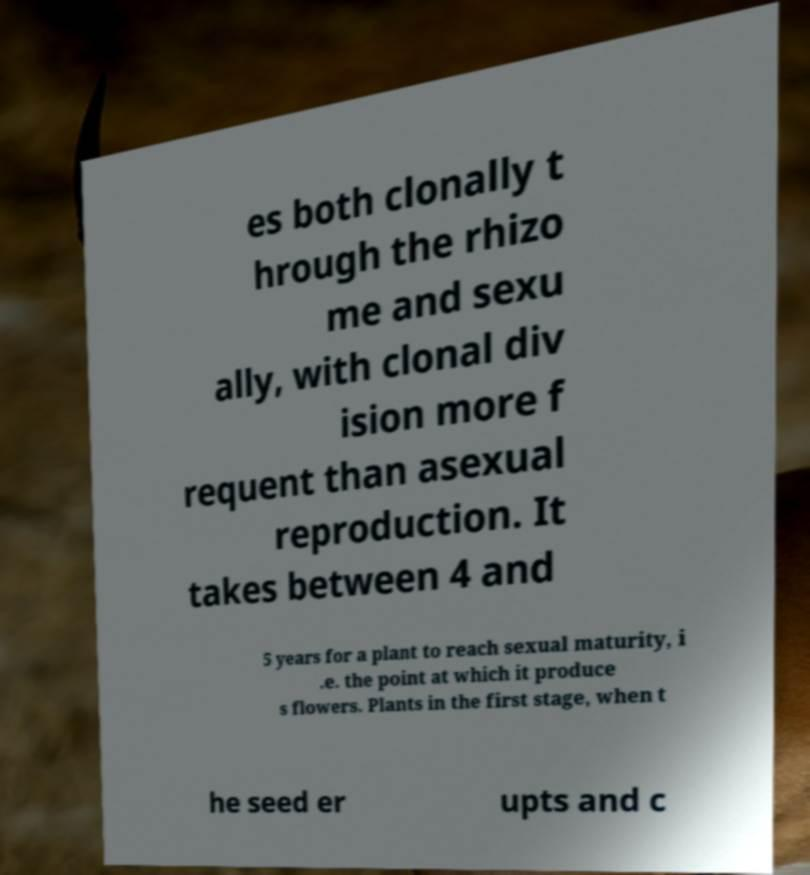Can you accurately transcribe the text from the provided image for me? es both clonally t hrough the rhizo me and sexu ally, with clonal div ision more f requent than asexual reproduction. It takes between 4 and 5 years for a plant to reach sexual maturity, i .e. the point at which it produce s flowers. Plants in the first stage, when t he seed er upts and c 